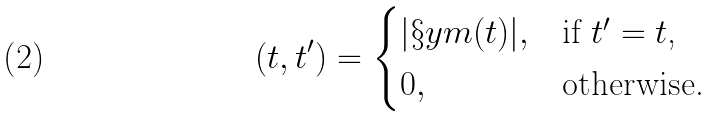<formula> <loc_0><loc_0><loc_500><loc_500>( t , t ^ { \prime } ) = \begin{cases} | \S y m ( t ) | , & \text {if $t^{\prime}=t$,} \\ 0 , & \text {otherwise.} \end{cases}</formula> 